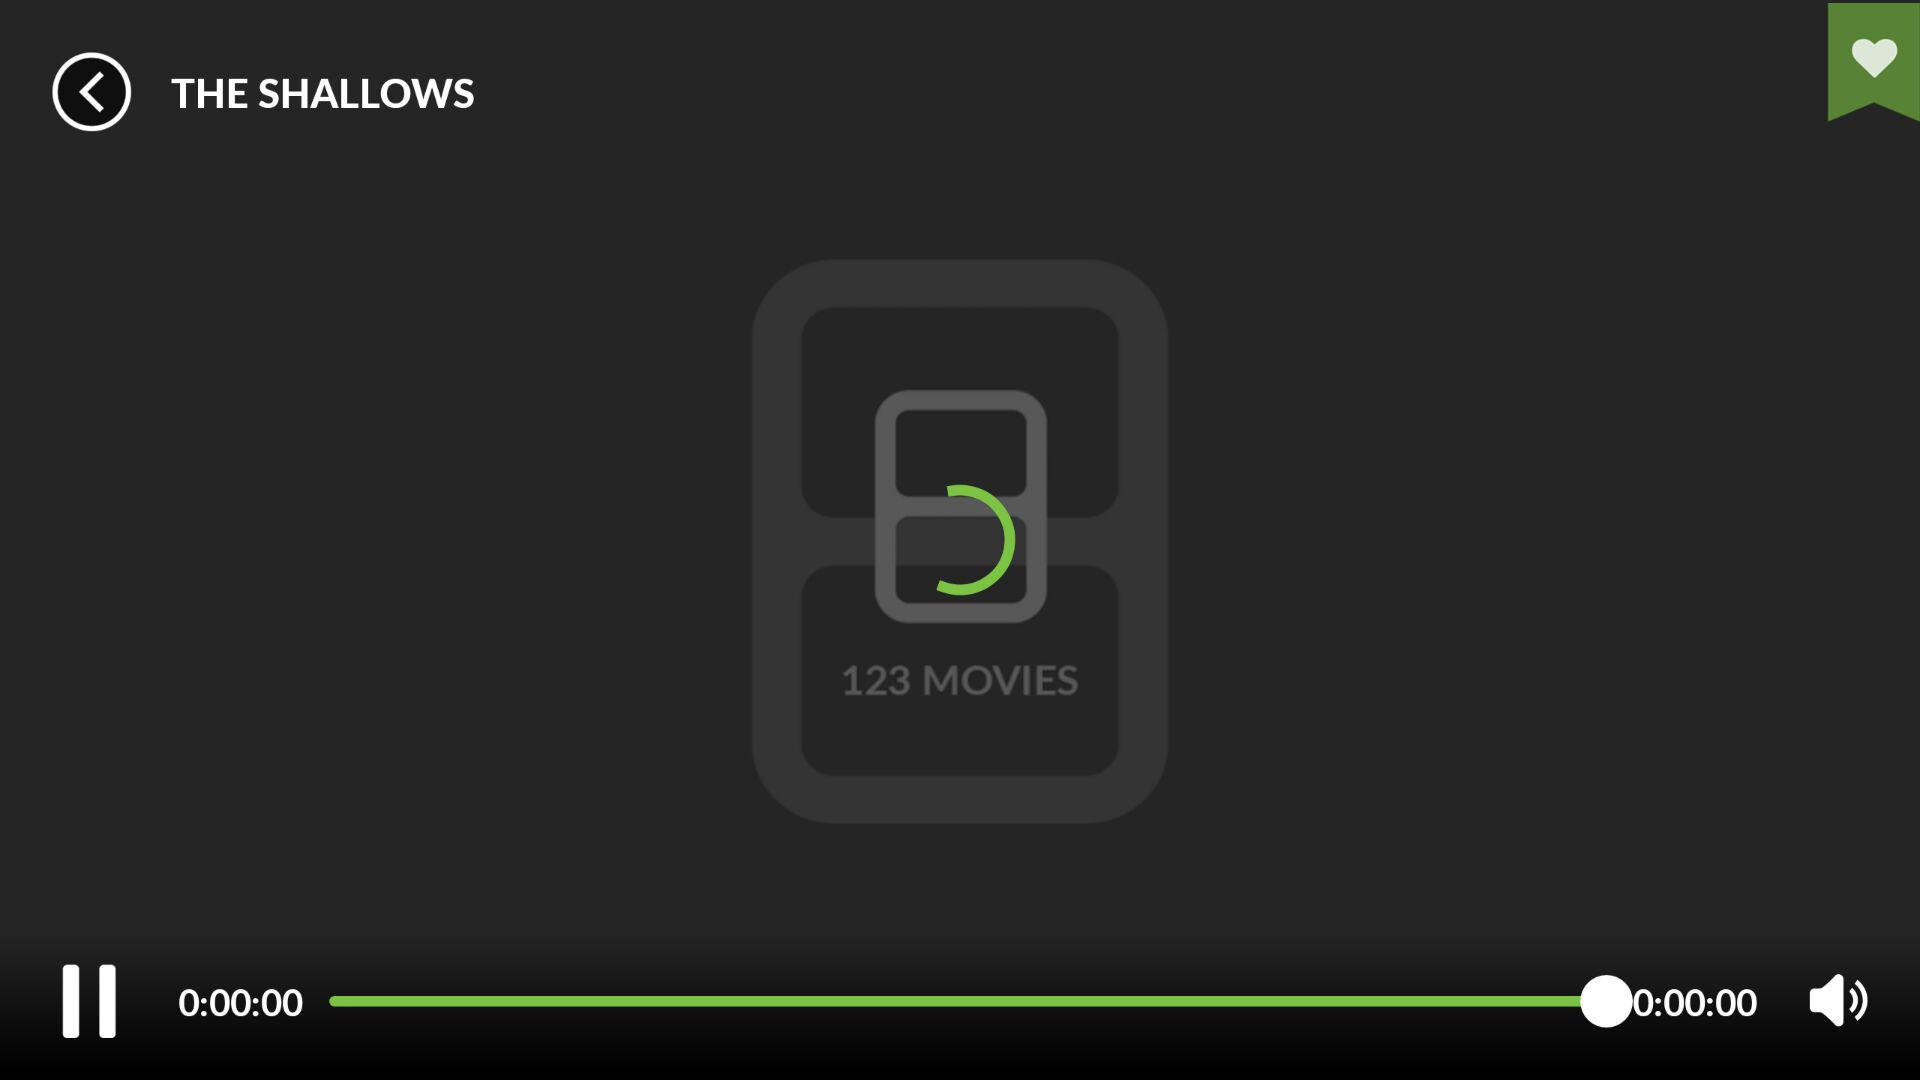How long is the video playing?
Answer the question using a single word or phrase. 0:00:00 